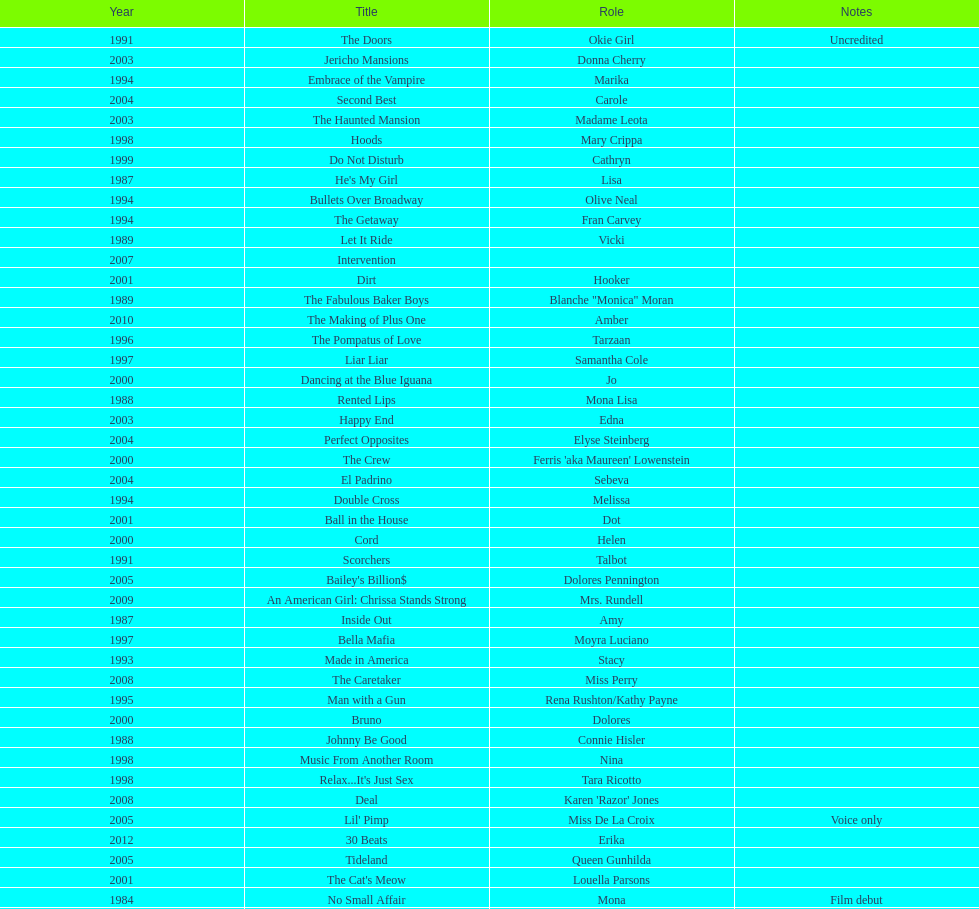How many movies does jennifer tilly play herself? 4. 